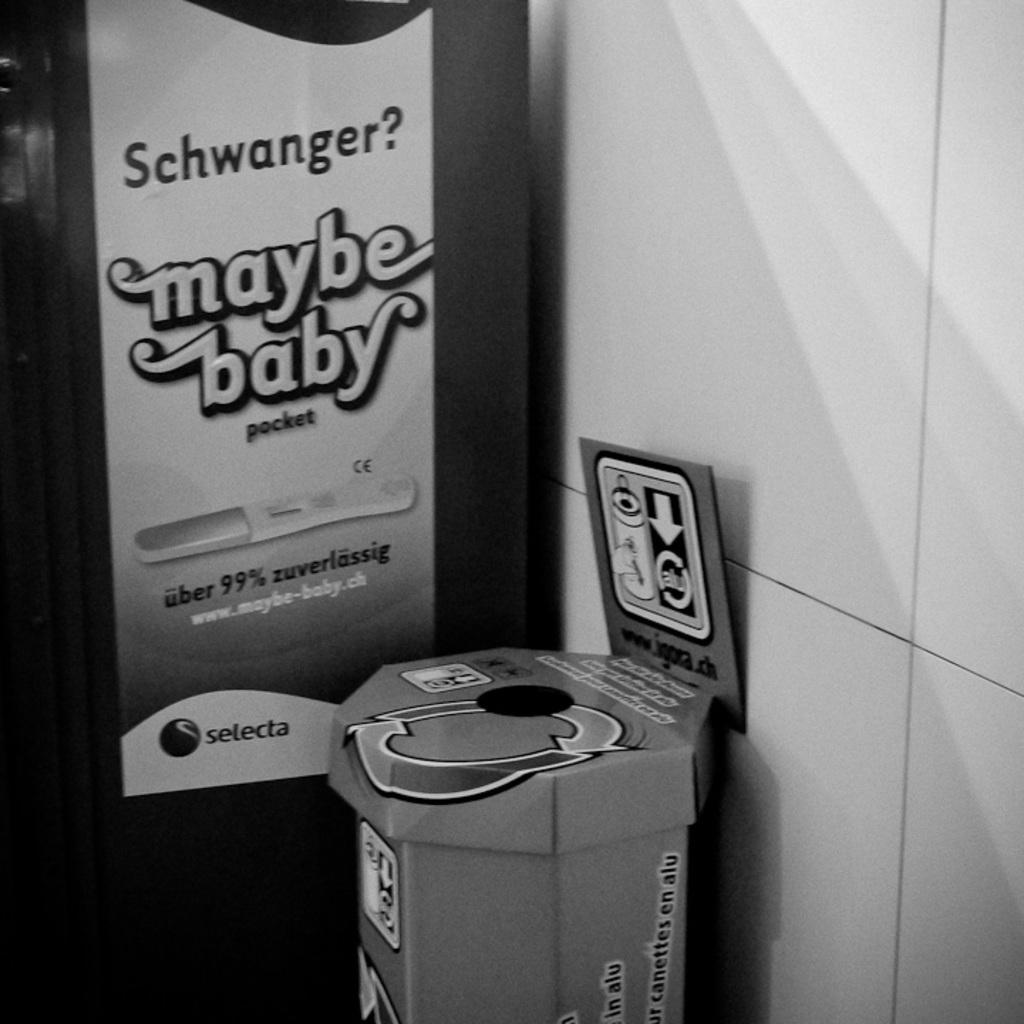<image>
Present a compact description of the photo's key features. A sign near a trash can says "maybe baby" and has a picture of a pregnancy test. 